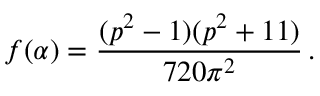Convert formula to latex. <formula><loc_0><loc_0><loc_500><loc_500>f ( \alpha ) = \frac { ( p ^ { 2 } - 1 ) ( p ^ { 2 } + 1 1 ) } { 7 2 0 \pi ^ { 2 } } \, .</formula> 